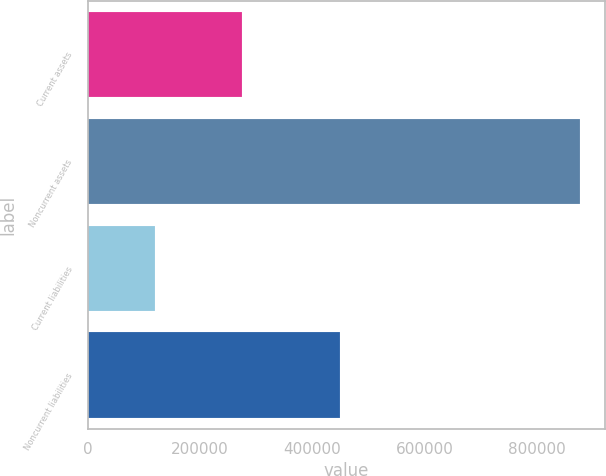<chart> <loc_0><loc_0><loc_500><loc_500><bar_chart><fcel>Current assets<fcel>Noncurrent assets<fcel>Current liabilities<fcel>Noncurrent liabilities<nl><fcel>274484<fcel>877402<fcel>119912<fcel>450156<nl></chart> 